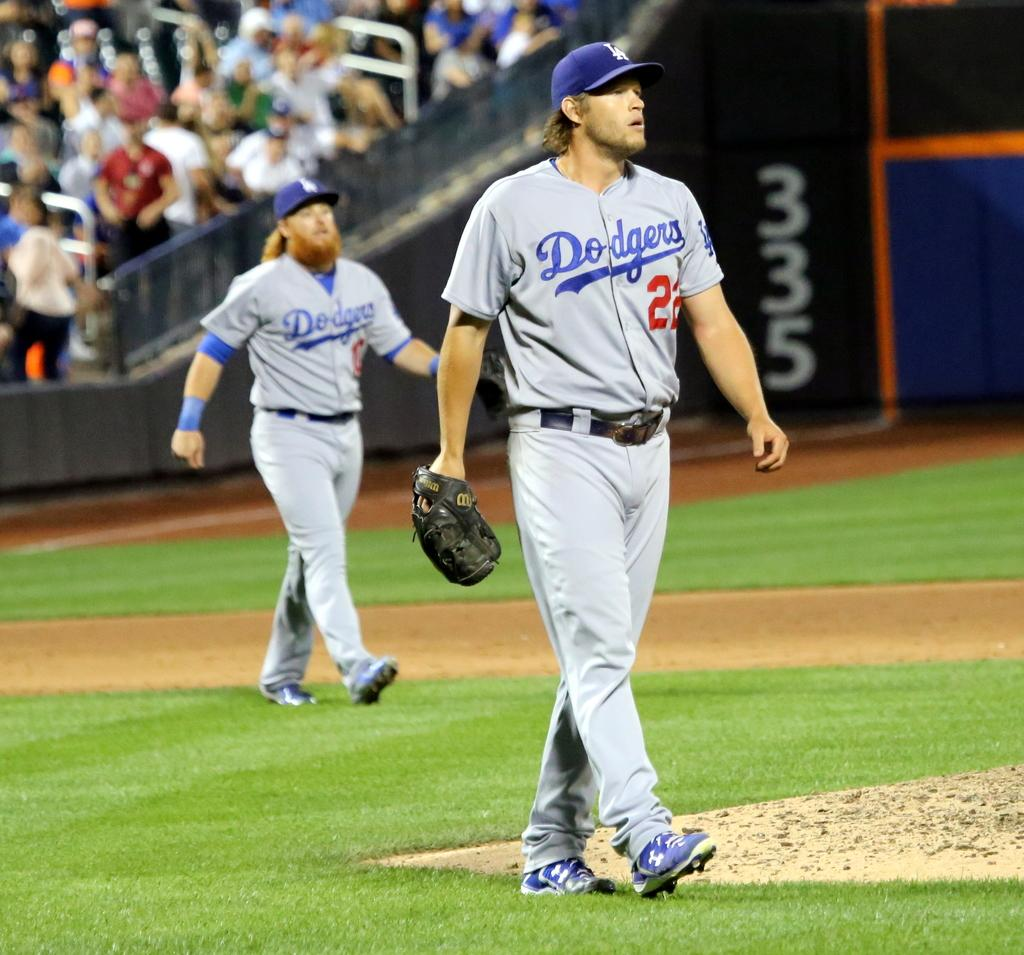<image>
Relay a brief, clear account of the picture shown. Two Dodger baseball players walk onto the field while the crowd watches. 